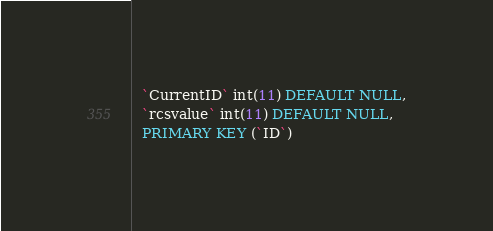Convert code to text. <code><loc_0><loc_0><loc_500><loc_500><_SQL_>  `CurrentID` int(11) DEFAULT NULL,
  `rcsvalue` int(11) DEFAULT NULL,
  PRIMARY KEY (`ID`)</code> 